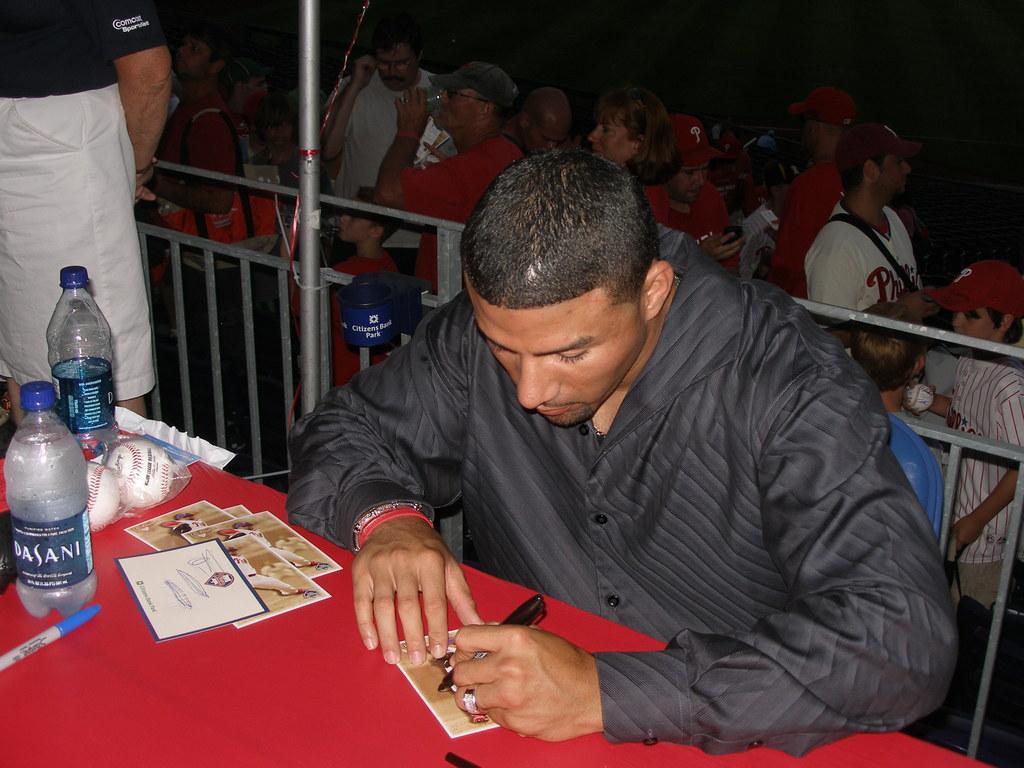Please provide a concise description of this image. In this image in the foreground there is one person who is sitting, and he is writing something. In front of him there is a table, on the table there are bottles, eggs and some cards, pens and on the left side there is another person. And in the background there is a railing, pole and some people. 